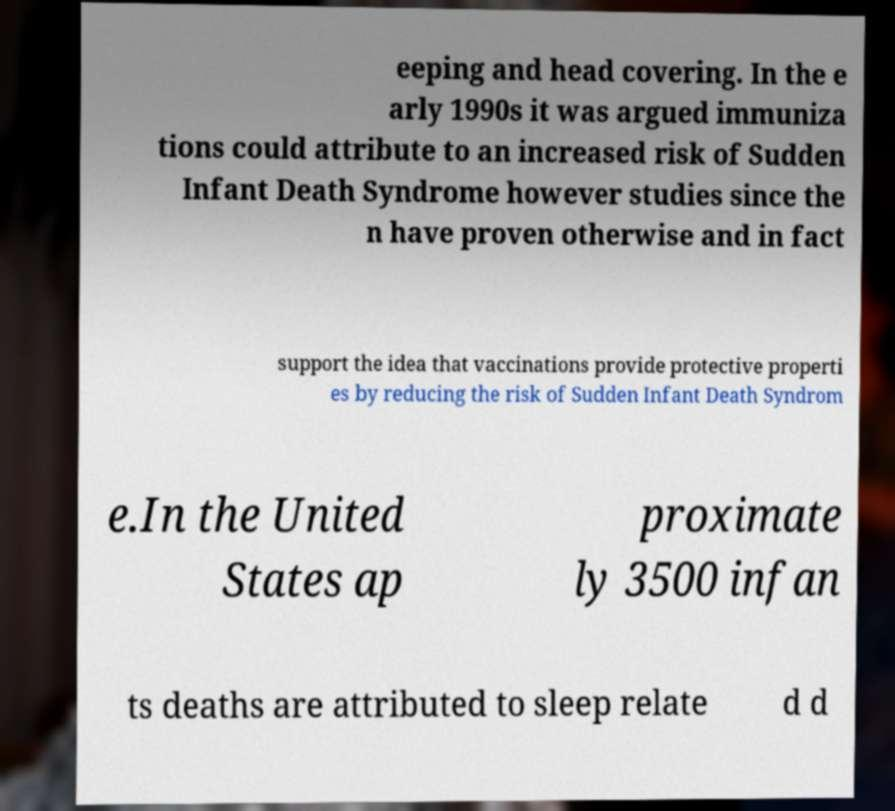Could you assist in decoding the text presented in this image and type it out clearly? eeping and head covering. In the e arly 1990s it was argued immuniza tions could attribute to an increased risk of Sudden Infant Death Syndrome however studies since the n have proven otherwise and in fact support the idea that vaccinations provide protective properti es by reducing the risk of Sudden Infant Death Syndrom e.In the United States ap proximate ly 3500 infan ts deaths are attributed to sleep relate d d 